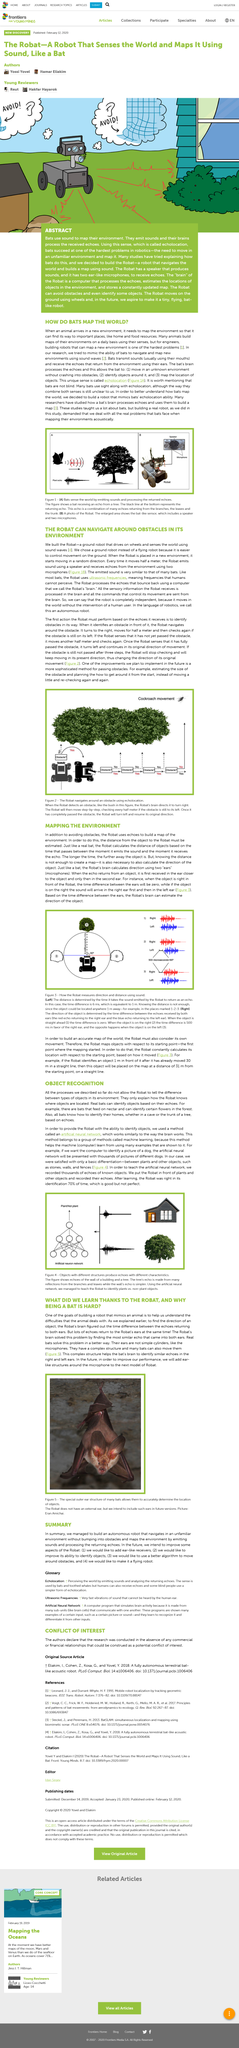Point out several critical features in this image. The Robat utilizes echoes of the real world to construct a map, mirroring the navigation techniques of a real bat. Bats typically use their mouths to transmit sounds. The animal depicted in Figure 5 is a bat. In the example for object recognition using the "robot", two objects, a house and a tree, are used for object recognition. The image depicts a robot using echolocation to navigate around an obstacle. 